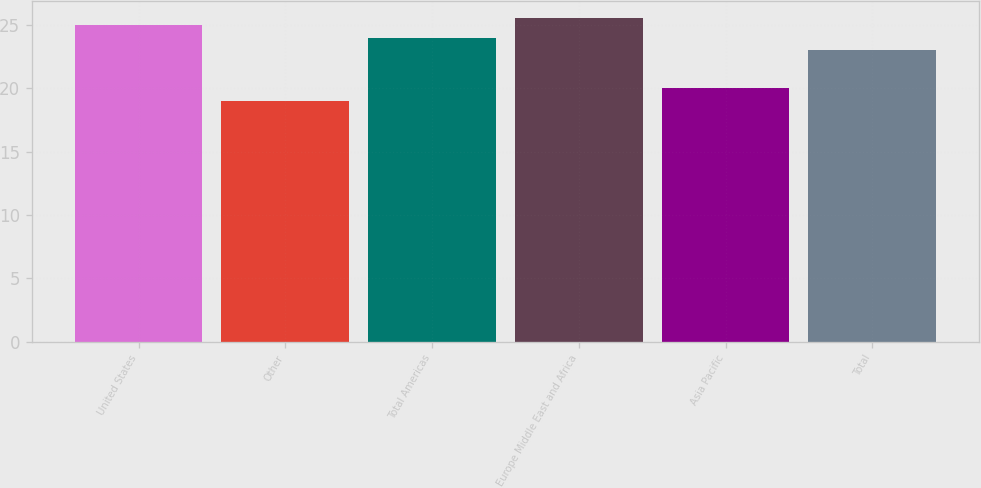Convert chart. <chart><loc_0><loc_0><loc_500><loc_500><bar_chart><fcel>United States<fcel>Other<fcel>Total Americas<fcel>Europe Middle East and Africa<fcel>Asia Pacific<fcel>Total<nl><fcel>25<fcel>19<fcel>24<fcel>25.6<fcel>20<fcel>23<nl></chart> 